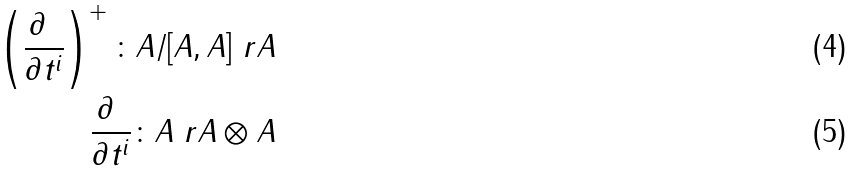<formula> <loc_0><loc_0><loc_500><loc_500>\left ( \frac { \partial \ } { \partial t ^ { i } } \right ) ^ { + } \colon A / [ A , A ] \ r A \\ \frac { \partial \ } { \partial t ^ { i } } \colon A \ r A \otimes A</formula> 